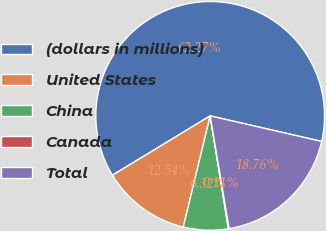<chart> <loc_0><loc_0><loc_500><loc_500><pie_chart><fcel>(dollars in millions)<fcel>United States<fcel>China<fcel>Canada<fcel>Total<nl><fcel>62.27%<fcel>12.54%<fcel>6.32%<fcel>0.11%<fcel>18.76%<nl></chart> 